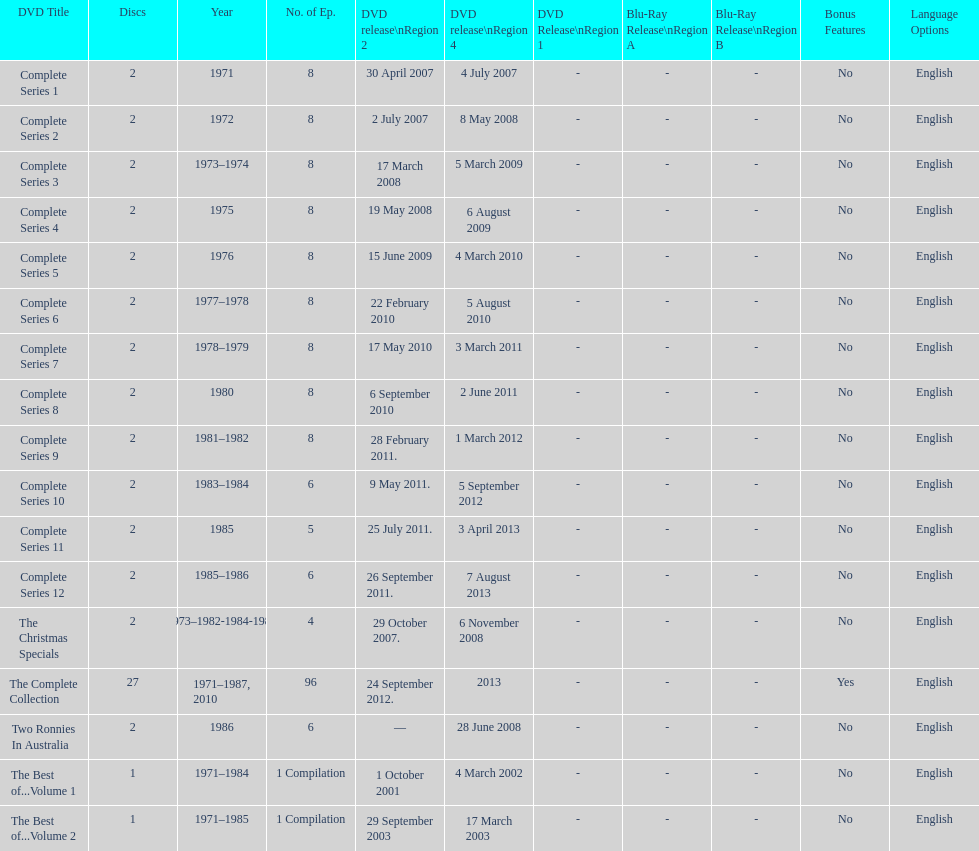The television show "the two ronnies" ran for a total of how many seasons? 12. 